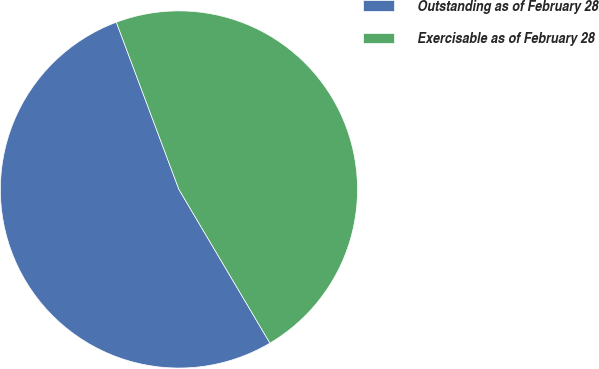Convert chart to OTSL. <chart><loc_0><loc_0><loc_500><loc_500><pie_chart><fcel>Outstanding as of February 28<fcel>Exercisable as of February 28<nl><fcel>52.81%<fcel>47.19%<nl></chart> 